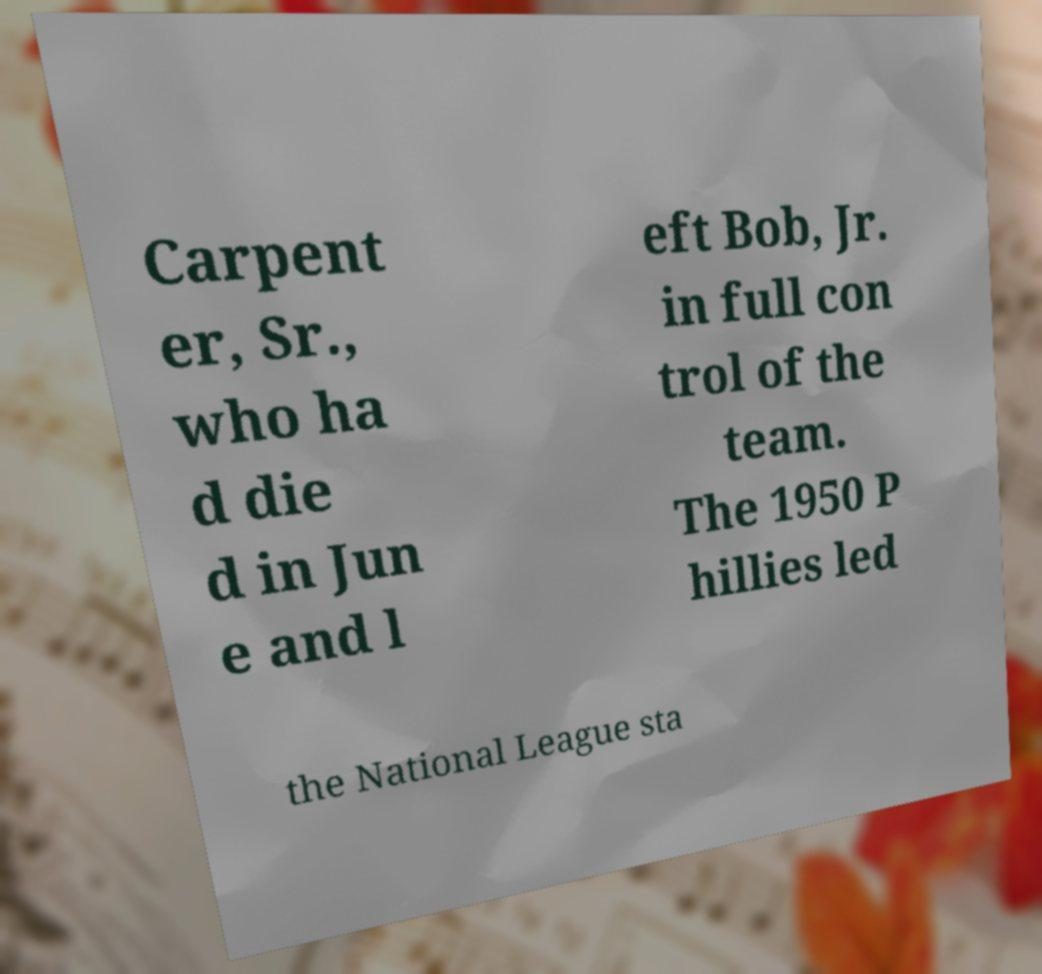Please identify and transcribe the text found in this image. Carpent er, Sr., who ha d die d in Jun e and l eft Bob, Jr. in full con trol of the team. The 1950 P hillies led the National League sta 